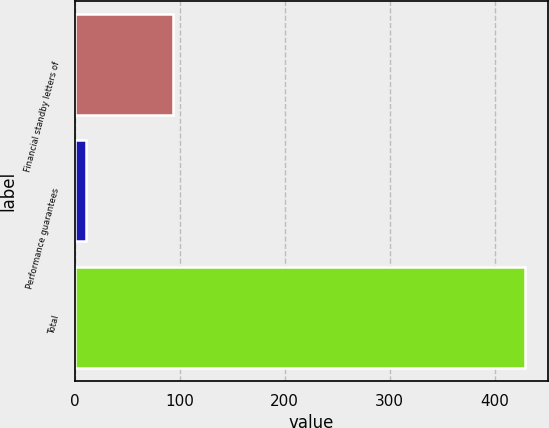Convert chart to OTSL. <chart><loc_0><loc_0><loc_500><loc_500><bar_chart><fcel>Financial standby letters of<fcel>Performance guarantees<fcel>Total<nl><fcel>93.8<fcel>11.3<fcel>429<nl></chart> 